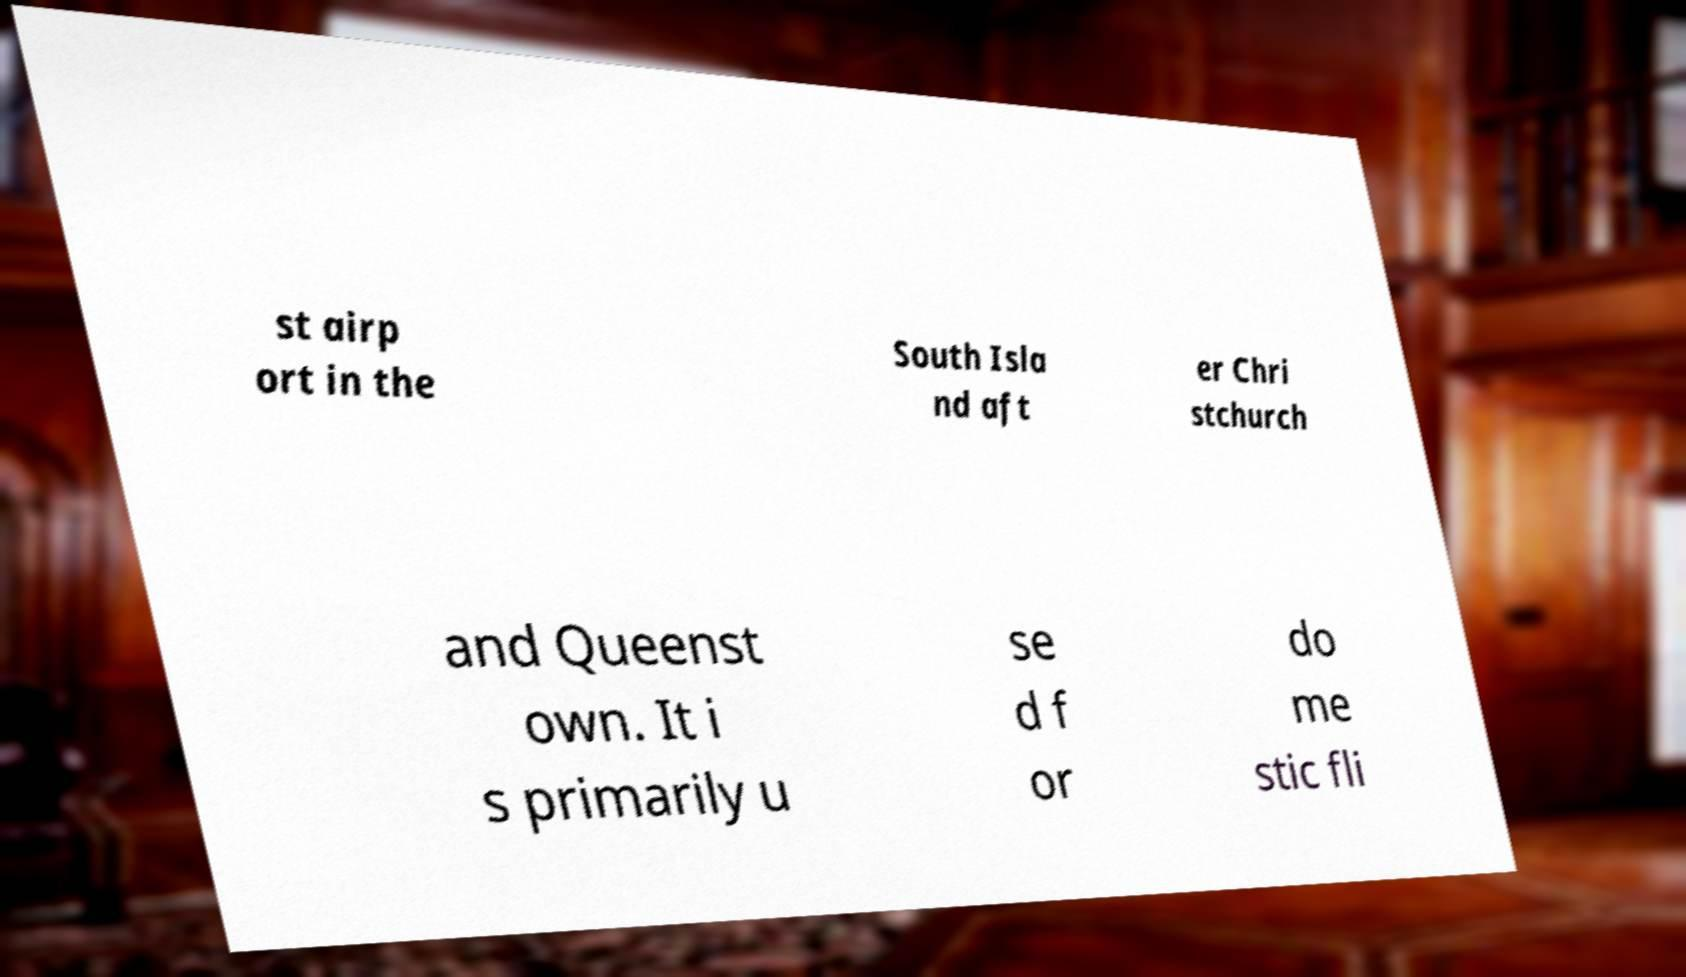There's text embedded in this image that I need extracted. Can you transcribe it verbatim? st airp ort in the South Isla nd aft er Chri stchurch and Queenst own. It i s primarily u se d f or do me stic fli 